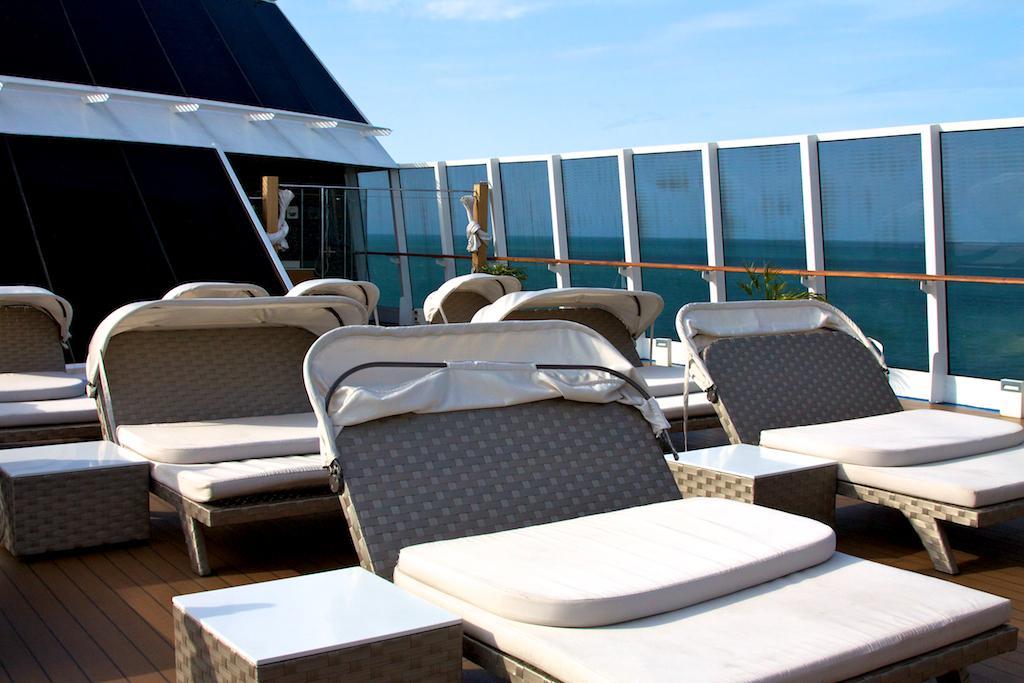Describe this image in one or two sentences. In this image I can see few beach beds, they are in white and gray color. I can see few glass walls, background the building is in white color and the sky is in blue and white color. 